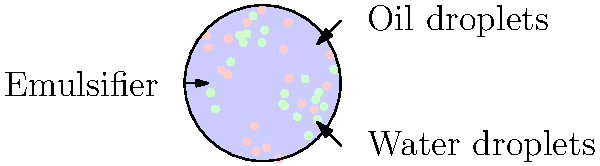As a food chemist, you're developing a new salad dressing. The diagram shows an emulsion of oil and water droplets stabilized by an emulsifier. What would happen to the stability of this emulsion if you were to increase the concentration of the emulsifier? Explain the mechanism behind this change and suggest how this knowledge could be applied to improve the shelf life of your salad dressing. To understand the effect of increasing emulsifier concentration on emulsion stability, let's break down the process:

1. Emulsion structure: The diagram shows oil and water droplets dispersed in a continuous phase, stabilized by an emulsifier.

2. Role of emulsifier:
   a. Emulsifiers are amphiphilic molecules with hydrophilic and hydrophobic parts.
   b. They reduce interfacial tension between oil and water phases.
   c. Emulsifiers form a protective layer around droplets, preventing coalescence.

3. Increasing emulsifier concentration:
   a. More emulsifier molecules available to cover droplet surfaces.
   b. Increased surface coverage leads to better stabilization.
   c. Smaller droplets can form and remain stable due to increased emulsifier availability.

4. Stability improvement mechanism:
   a. Steric hindrance: Emulsifier layers on droplets create physical barriers against coalescence.
   b. Electrostatic repulsion: Some emulsifiers impart charge to droplets, causing repulsion.
   c. Gibbs-Marangoni effect: Emulsifiers maintain uniform interfacial tension, resisting droplet coalescence.

5. Impact on emulsion stability:
   a. Reduced droplet size: Smaller droplets are less prone to gravitational separation.
   b. Increased kinetic stability: Brownian motion keeps smaller droplets suspended longer.
   c. Enhanced thermodynamic stability: Lower interfacial tension reduces the drive for phase separation.

6. Application to salad dressing shelf life:
   a. Optimized emulsifier concentration can prevent oil-water separation during storage.
   b. Smaller, stable droplets improve texture and mouthfeel of the dressing.
   c. Resistance to environmental stresses (temperature changes, shear) is enhanced.
   d. Potential for reducing or eliminating the need for additional stabilizers.

In summary, increasing emulsifier concentration generally improves emulsion stability by enhancing droplet coverage, reducing droplet size, and strengthening the barriers against coalescence. This knowledge can be applied to develop a salad dressing with improved shelf life, texture, and overall quality.
Answer: Increasing emulsifier concentration improves emulsion stability by enhancing droplet coverage, reducing droplet size, and strengthening barriers against coalescence, leading to extended shelf life and improved texture in the salad dressing. 